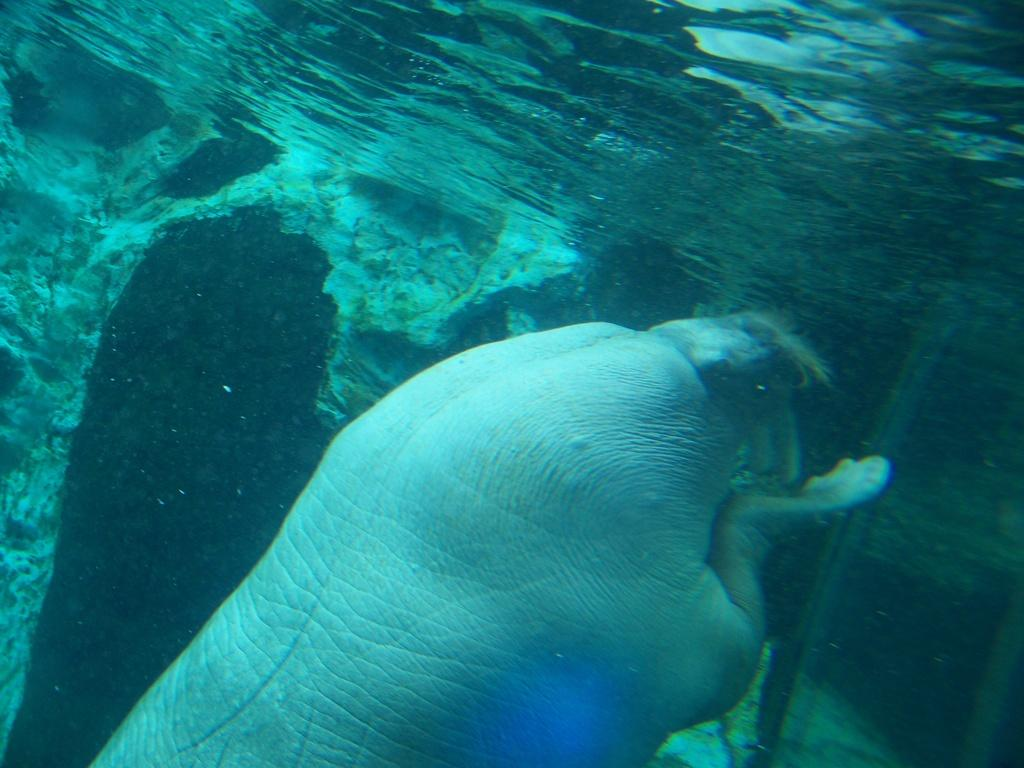What is the primary element visible in the image? There is water in the image. Can you describe any living organisms present in the image? There is an animal under the water in the image. What type of beef is being used as bait in the image? There is no beef or bait present in the image; it only features water and an animal under the water. 